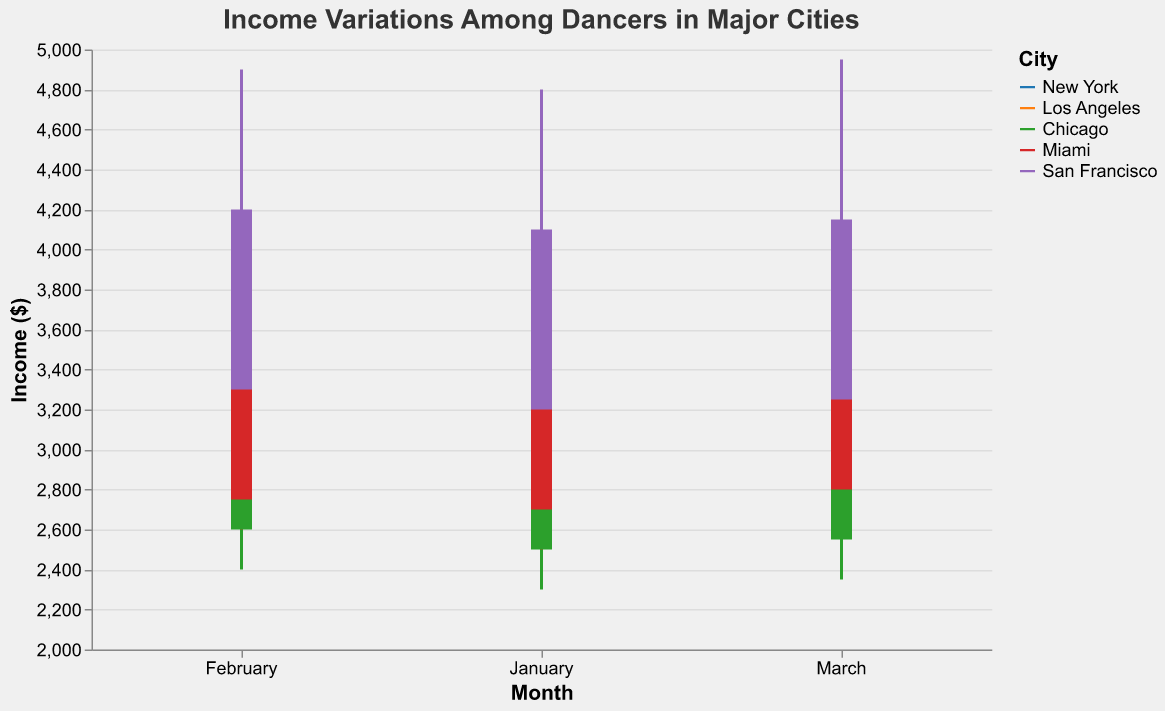What is the highest income recorded in New York in January? Look at the "High" column for New York in January, which is listed as 4500.
Answer: 4500 How does the income range (difference between High and Low) in Los Angeles in February compare to that in Miami in February? Calculate the range for both cities in February: Los Angeles 4250-2750=1500, Miami 4150-2600=1550. Compare the two values.
Answer: Los Angeles: 1500, Miami: 1550 What city had the highest closing income in March? Check the "Close" values for March across all cities. San Francisco has the highest with 4150.
Answer: San Francisco Which city's income showed the smallest increase from January to February in the Opening values? Calculate the difference in Open values from January to February for each city: New York (3200-3000=200), Los Angeles (2900-2800=100), Chicago (2600-2500=100), Miami (2750-2700=50), San Francisco (3300-3200=100). Miami has the smallest increase, 50.
Answer: Miami In which month did New York have the highest closing income? Compare the "Close" values for each month in New York: January (3750), February (3800), and March (3900). March is the highest.
Answer: March How does the income variation in Chicago in January compare to Los Angeles in March? Calculate the range for each: Chicago (4000-2300=1700), Los Angeles (4300-2700=1600). Chicago has a larger variation.
Answer: Chicago: 1700, Los Angeles: 1600 What is the average high income for San Francisco over the three months? Sum the "High" values for San Francisco over the three months: (4800 + 4900 + 4950=14650), then divide by 3: 14650/3.
Answer: 4883.33 Which city consistently had a closing income greater than its opening income every month? Check "Open" and "Close" values for each city in each month and see if the "Close" is consistently higher: New York, Los Angeles, Chicago, Miami, San Francisco: San Francisco consistently shows Closing > Opening.
Answer: San Francisco By how much did the high income difference between January and March change for Miami? Calculate the high income difference: January to March is (4200-4100)=100.
Answer: 100 